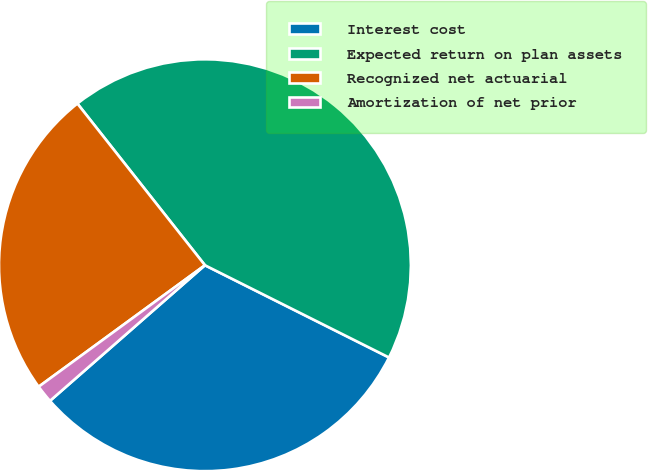<chart> <loc_0><loc_0><loc_500><loc_500><pie_chart><fcel>Interest cost<fcel>Expected return on plan assets<fcel>Recognized net actuarial<fcel>Amortization of net prior<nl><fcel>31.16%<fcel>43.02%<fcel>24.41%<fcel>1.4%<nl></chart> 